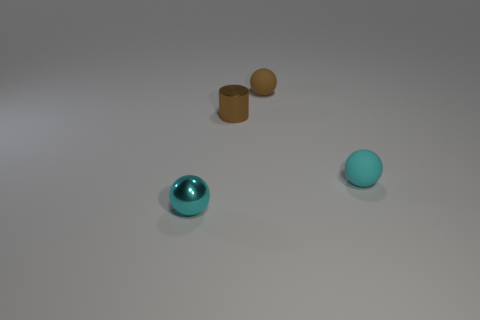Subtract all purple balls. Subtract all blue cylinders. How many balls are left? 3 Add 3 green balls. How many objects exist? 7 Subtract all cylinders. How many objects are left? 3 Subtract 0 red cylinders. How many objects are left? 4 Subtract all tiny cyan metallic spheres. Subtract all big cylinders. How many objects are left? 3 Add 4 brown balls. How many brown balls are left? 5 Add 1 tiny red spheres. How many tiny red spheres exist? 1 